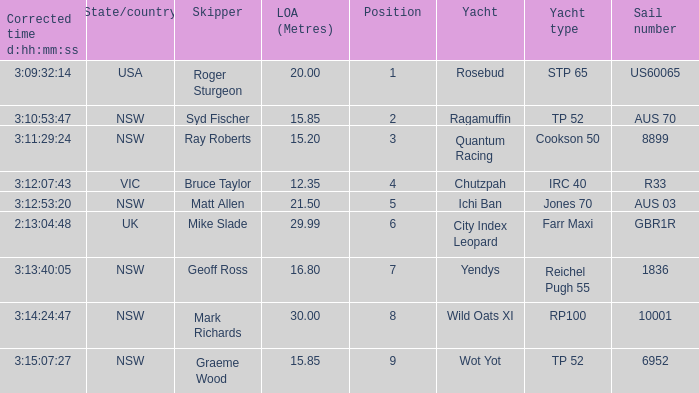What are all sail numbers for the yacht Yendys? 1836.0. 